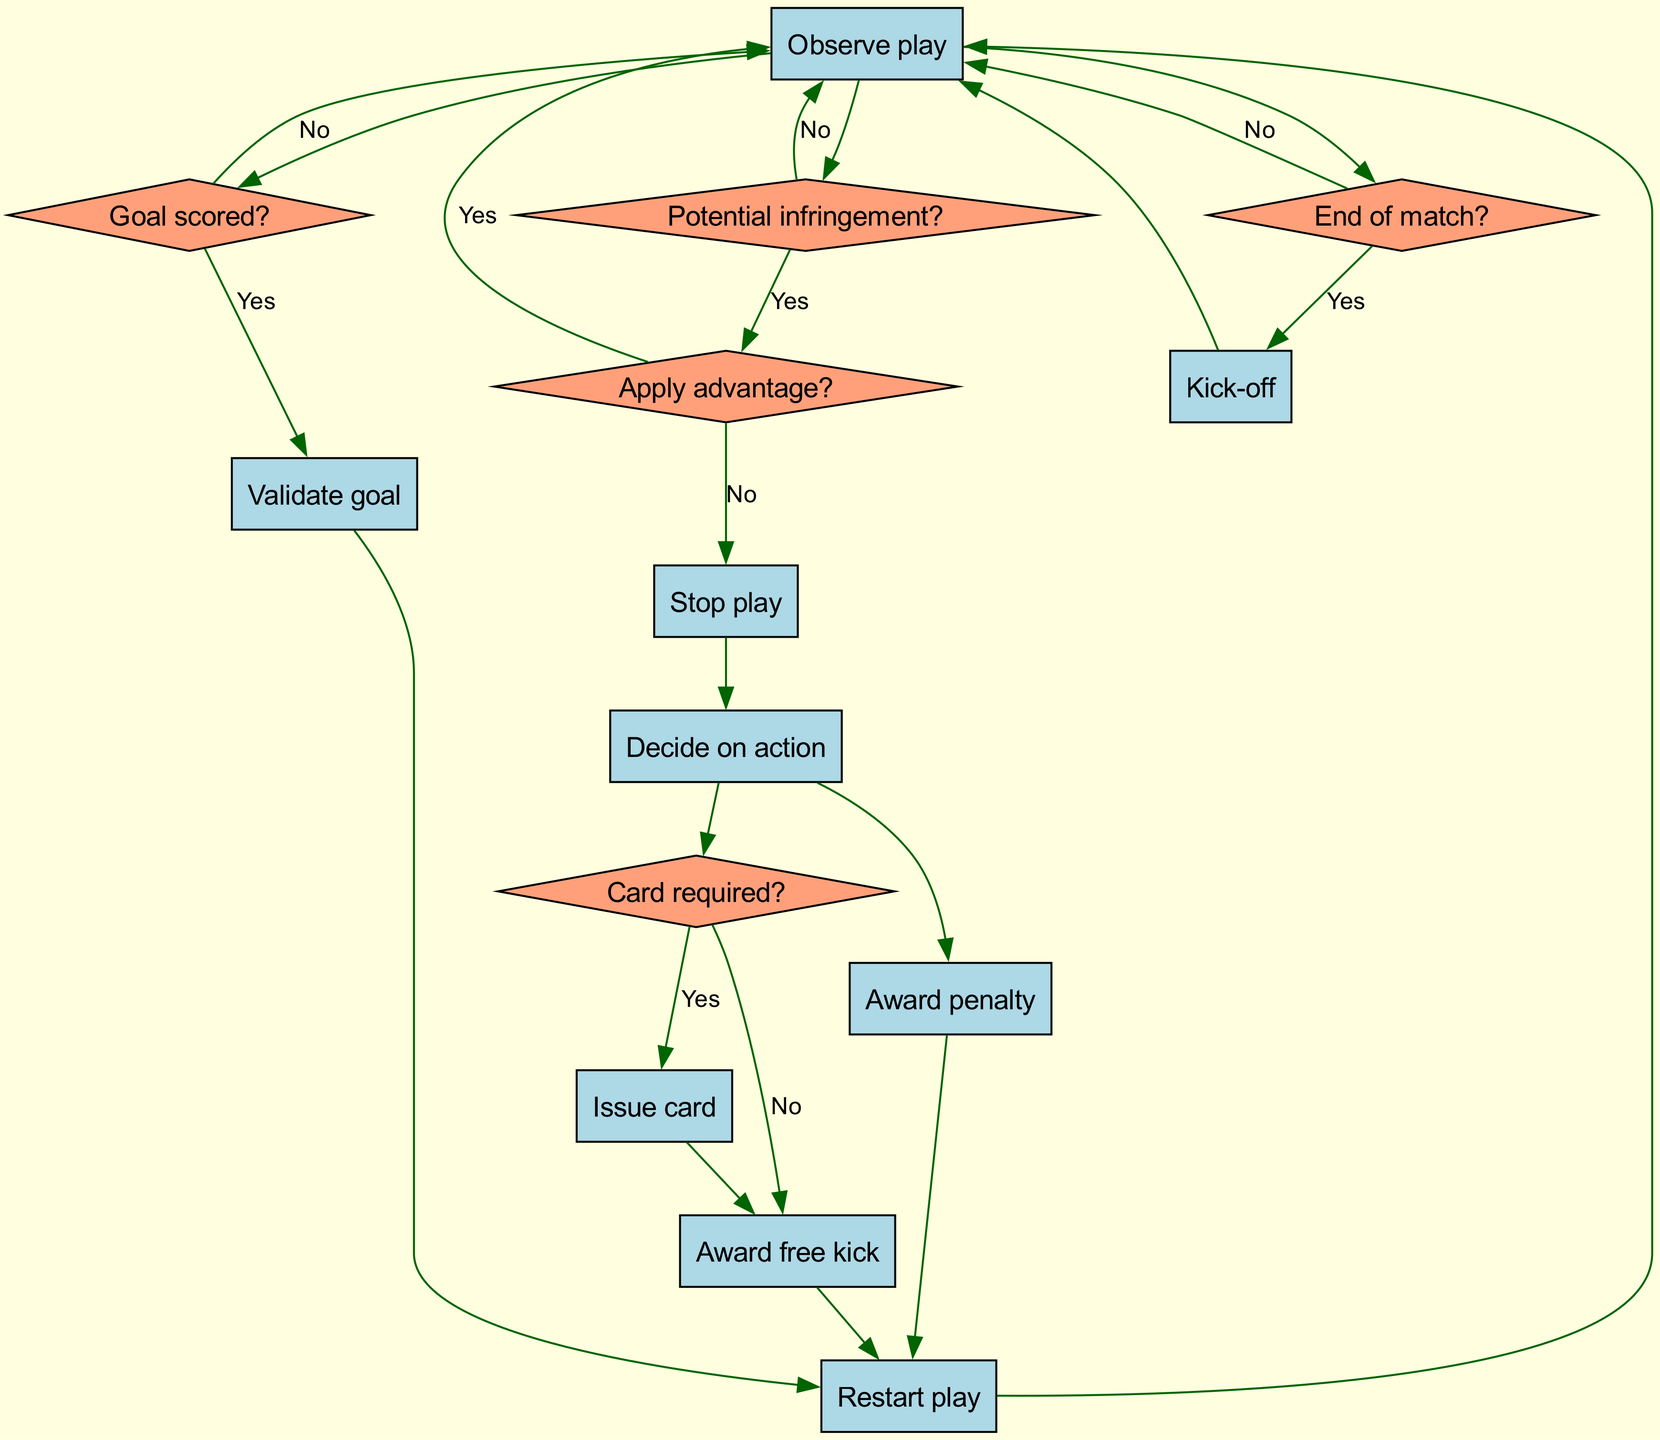What is the first action in the flow? The flow starts with the "Kick-off" action, indicating the beginning of the match and the first step in the referee's decision-making process.
Answer: Kick-off How many nodes are in the diagram? The diagram contains a total of 13 nodes being used in the flow, including the starting node.
Answer: 13 What happens if there is no potential infringement? If there is no potential infringement, the referee returns to "Observe play," which indicates a continuation of monitoring the game without stopping.
Answer: Observe play What action follows "Decide on action"? After "Decide on action," the process leads to "Card required?" to determine if a card needs to be issued for the observed actions.
Answer: Card required? What is the relationship between "Award penalty" and "Restart play"? The "Award penalty" node passes directly to "Restart play," indicating that after a penalty is awarded, the match resumes with the appropriate restart procedure.
Answer: Restart play If a goal is scored, what must the referee do next? If a goal is scored, the referee first needs to "Validate goal," ensuring that all conditions for a valid goal are met before proceeding.
Answer: Validate goal What happens after the match ends? Once the "End of match?" question is addressed, if the answer is "Yes," it loops back to "Kick-off," but if the answer is "No," it leads back to "Observe play."
Answer: Kick-off How does the decision process handle a card being issued? If a card is required, after "Card required?," the referee proceeds to "Issue card," which then connects to "Award free kick," reflecting the consequences following the issuance of a card.
Answer: Award free kick What do the diamond-shaped nodes represent? The diamond-shaped nodes in the flowchart represent decision points that require a yes or no response to guide the referee's actions based on that decision.
Answer: Decision points 